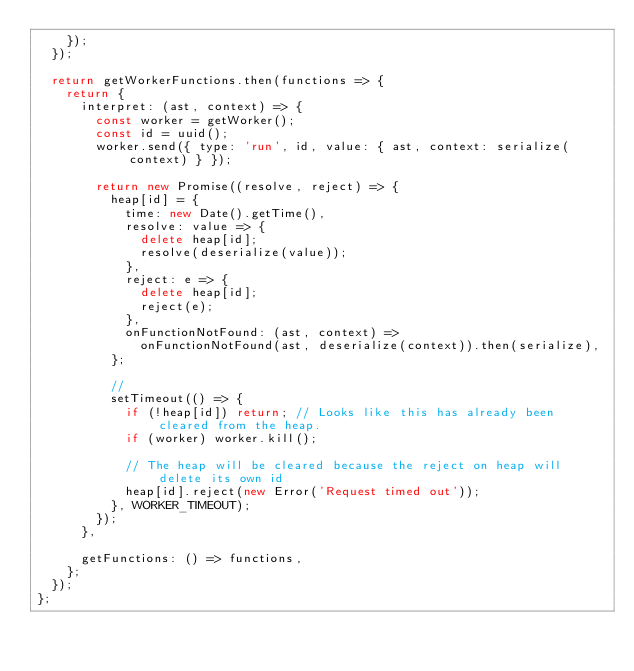<code> <loc_0><loc_0><loc_500><loc_500><_JavaScript_>    });
  });

  return getWorkerFunctions.then(functions => {
    return {
      interpret: (ast, context) => {
        const worker = getWorker();
        const id = uuid();
        worker.send({ type: 'run', id, value: { ast, context: serialize(context) } });

        return new Promise((resolve, reject) => {
          heap[id] = {
            time: new Date().getTime(),
            resolve: value => {
              delete heap[id];
              resolve(deserialize(value));
            },
            reject: e => {
              delete heap[id];
              reject(e);
            },
            onFunctionNotFound: (ast, context) =>
              onFunctionNotFound(ast, deserialize(context)).then(serialize),
          };

          //
          setTimeout(() => {
            if (!heap[id]) return; // Looks like this has already been cleared from the heap.
            if (worker) worker.kill();

            // The heap will be cleared because the reject on heap will delete its own id
            heap[id].reject(new Error('Request timed out'));
          }, WORKER_TIMEOUT);
        });
      },

      getFunctions: () => functions,
    };
  });
};
</code> 